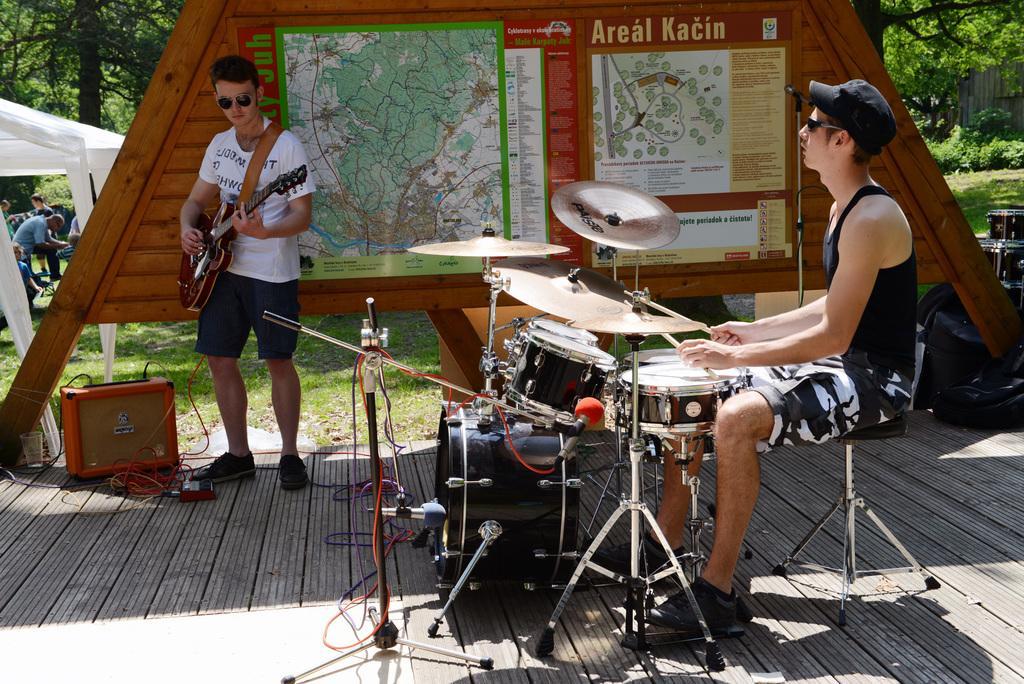Please provide a concise description of this image. Here I can see two men. The man who is on the right side is sitting and playing the drums. Another man is standing and playing a guitar. Beside him there is a box placed on a wooden surface and at the back of this man there is a wooden board on which few posters are attached. On the left side there is a tent and I can see few people. In the background there are many trees. On the right side there are few bags. In the middle of the image there are many musical instruments placed on a wooden surface. 